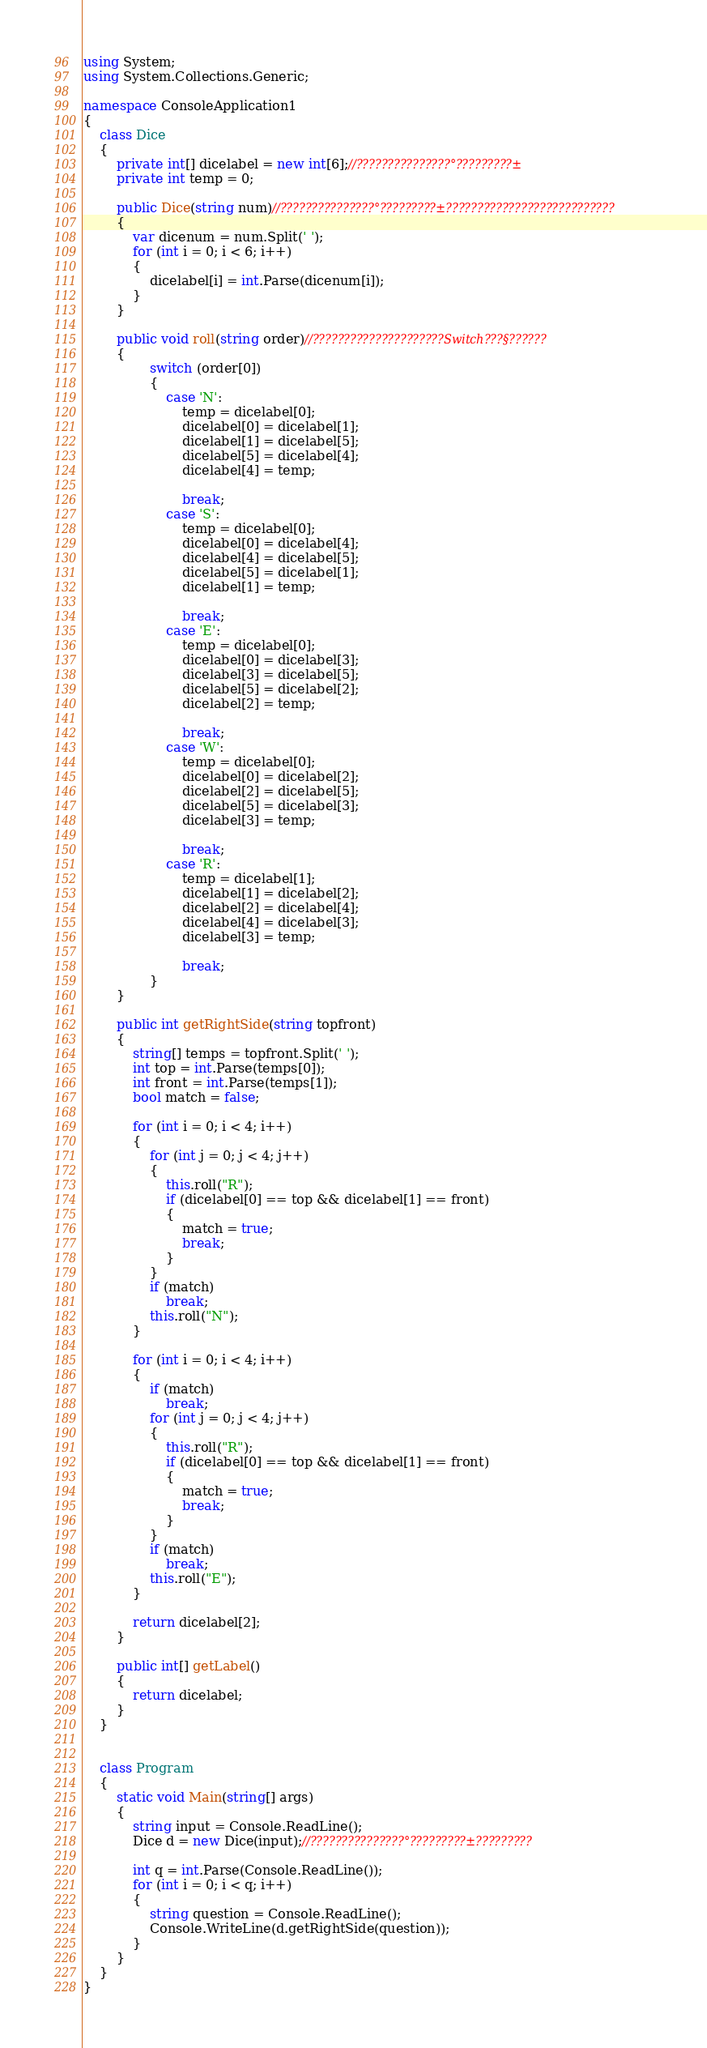<code> <loc_0><loc_0><loc_500><loc_500><_C#_>using System;
using System.Collections.Generic;

namespace ConsoleApplication1
{
    class Dice
    {
        private int[] dicelabel = new int[6];//???????????????°?????????±
        private int temp = 0;

        public Dice(string num)//???????????????°?????????±???????????????????????????
        {
            var dicenum = num.Split(' ');
            for (int i = 0; i < 6; i++)
            {
                dicelabel[i] = int.Parse(dicenum[i]);
            }
        }

        public void roll(string order)//?????????????????????Switch???§??????
        {
                switch (order[0])
                {
                    case 'N':
                        temp = dicelabel[0];
                        dicelabel[0] = dicelabel[1];
                        dicelabel[1] = dicelabel[5];
                        dicelabel[5] = dicelabel[4];
                        dicelabel[4] = temp;

                        break;
                    case 'S':
                        temp = dicelabel[0];
                        dicelabel[0] = dicelabel[4];
                        dicelabel[4] = dicelabel[5];
                        dicelabel[5] = dicelabel[1];
                        dicelabel[1] = temp;

                        break;
                    case 'E':
                        temp = dicelabel[0];
                        dicelabel[0] = dicelabel[3];
                        dicelabel[3] = dicelabel[5];
                        dicelabel[5] = dicelabel[2];
                        dicelabel[2] = temp;

                        break;
                    case 'W':
                        temp = dicelabel[0];
                        dicelabel[0] = dicelabel[2];
                        dicelabel[2] = dicelabel[5];
                        dicelabel[5] = dicelabel[3];
                        dicelabel[3] = temp;

                        break;
                    case 'R':
                        temp = dicelabel[1];
                        dicelabel[1] = dicelabel[2];
                        dicelabel[2] = dicelabel[4];
                        dicelabel[4] = dicelabel[3];
                        dicelabel[3] = temp;

                        break;
                }
        }

        public int getRightSide(string topfront)
        {
            string[] temps = topfront.Split(' ');
            int top = int.Parse(temps[0]);
            int front = int.Parse(temps[1]);
            bool match = false;

            for (int i = 0; i < 4; i++)
            {
                for (int j = 0; j < 4; j++)
                {
                    this.roll("R");
                    if (dicelabel[0] == top && dicelabel[1] == front)
                    {
                        match = true;
                        break;
                    }
                }
                if (match)
                    break;
                this.roll("N");
            }

            for (int i = 0; i < 4; i++)
            {
                if (match)
                    break;
                for (int j = 0; j < 4; j++)
                {
                    this.roll("R");
                    if (dicelabel[0] == top && dicelabel[1] == front)
                    {
                        match = true;
                        break;
                    }
                }
                if (match)
                    break;
                this.roll("E");
            }

            return dicelabel[2];
        }

        public int[] getLabel()
        {
            return dicelabel;
        }
    }


    class Program
    {
        static void Main(string[] args)
        {
            string input = Console.ReadLine();
            Dice d = new Dice(input);//???????????????°?????????±?????????

            int q = int.Parse(Console.ReadLine());
            for (int i = 0; i < q; i++)
            {
                string question = Console.ReadLine();
                Console.WriteLine(d.getRightSide(question));
            }
        }
    }
}</code> 